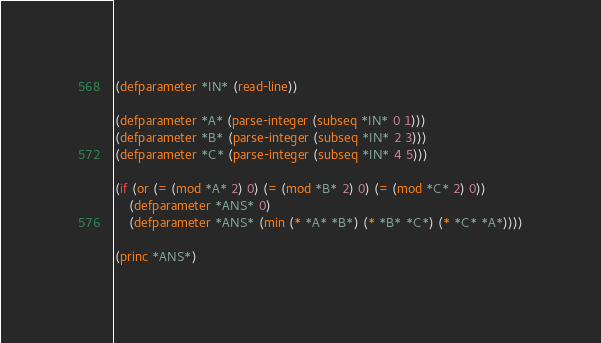<code> <loc_0><loc_0><loc_500><loc_500><_Lisp_>(defparameter *IN* (read-line))

(defparameter *A* (parse-integer (subseq *IN* 0 1)))
(defparameter *B* (parse-integer (subseq *IN* 2 3)))
(defparameter *C* (parse-integer (subseq *IN* 4 5)))

(if (or (= (mod *A* 2) 0) (= (mod *B* 2) 0) (= (mod *C* 2) 0))
    (defparameter *ANS* 0)
    (defparameter *ANS* (min (* *A* *B*) (* *B* *C*) (* *C* *A*))))

(princ *ANS*)</code> 